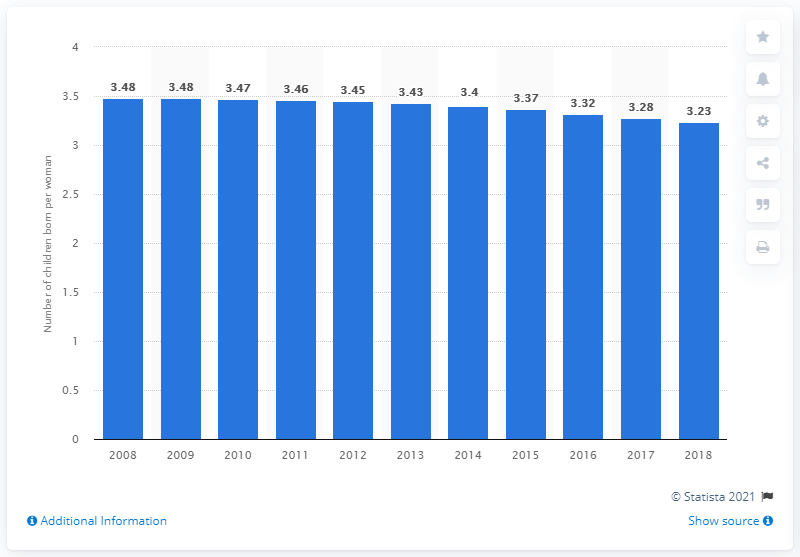Point out several critical features in this image. According to data from 2018, the fertility rate in the Arab world was 3.23. 